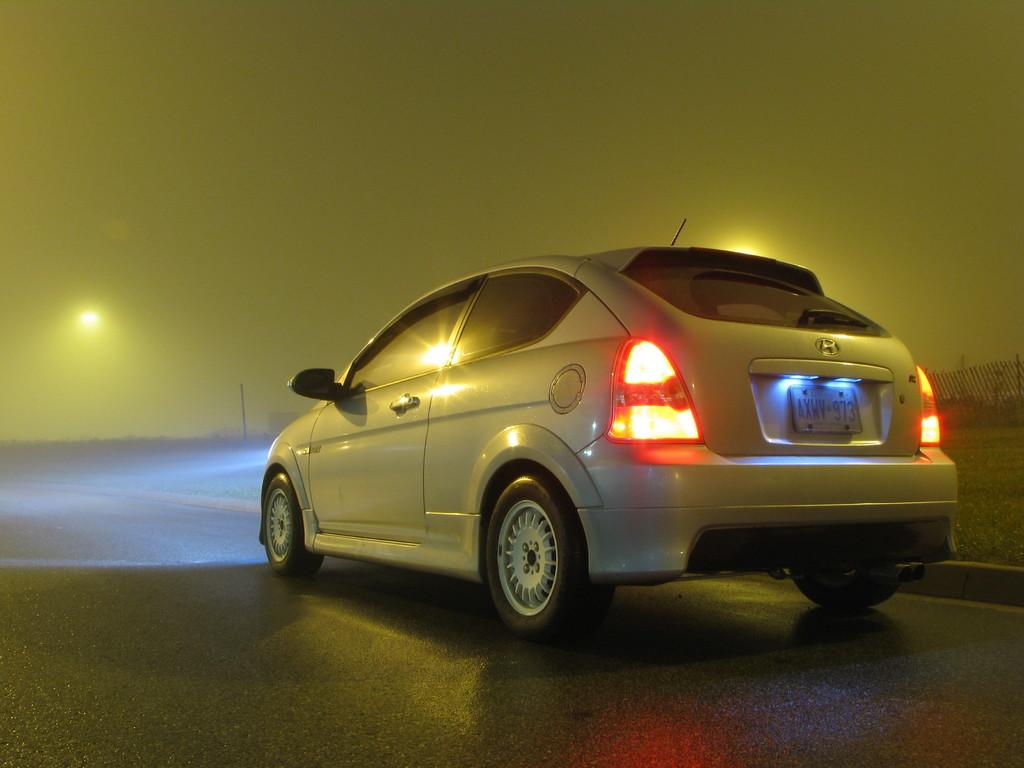What is the license plate number?
Provide a short and direct response. Axwv973. 